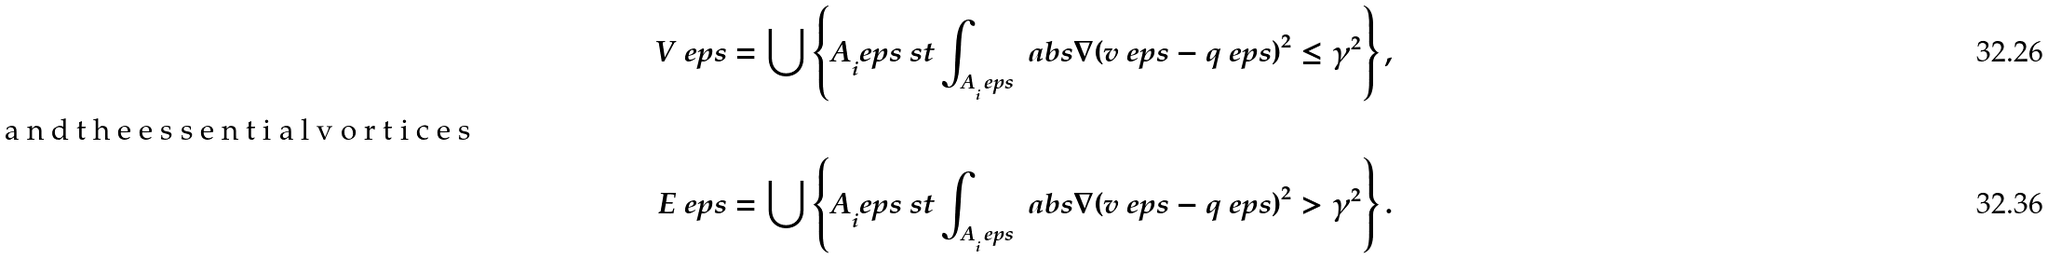Convert formula to latex. <formula><loc_0><loc_0><loc_500><loc_500>V ^ { \ } e p s & = \bigcup \left \{ A _ { i } ^ { \ } e p s \ s t \int _ { A _ { i } ^ { \ } e p s } \ a b s { \nabla ( v ^ { \ } e p s - q ^ { \ } e p s ) } ^ { 2 } \leq \gamma ^ { 2 } \right \} , \\ \intertext { a n d t h e e s s e n t i a l v o r t i c e s } E ^ { \ } e p s & = \bigcup \left \{ A _ { i } ^ { \ } e p s \ s t \int _ { A _ { i } ^ { \ } e p s } \ a b s { \nabla ( v ^ { \ } e p s - q ^ { \ } e p s ) } ^ { 2 } > \gamma ^ { 2 } \right \} .</formula> 